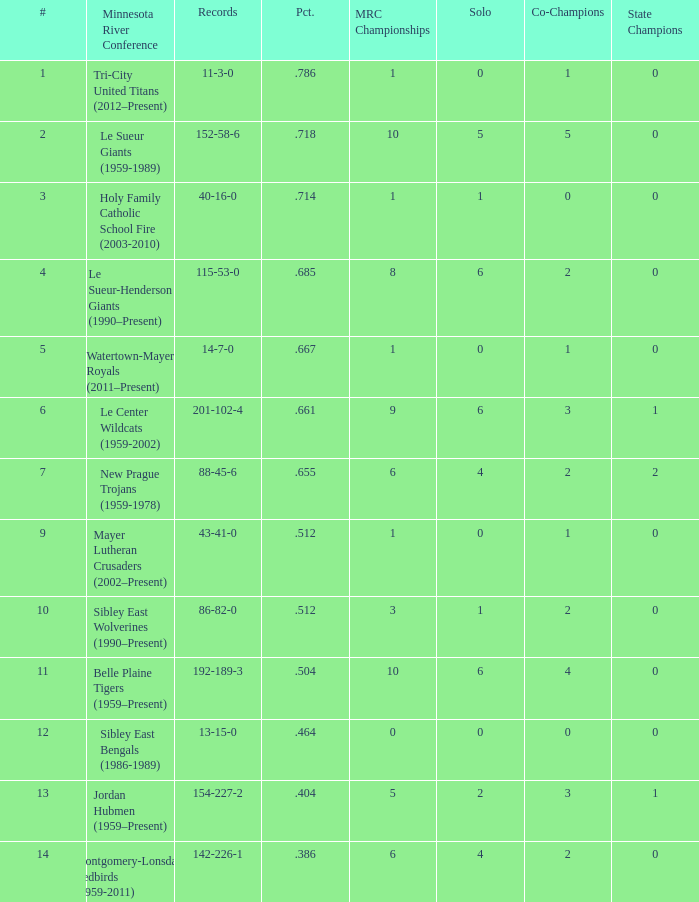How many teams are #2 on the list? 1.0. Would you mind parsing the complete table? {'header': ['#', 'Minnesota River Conference', 'Records', 'Pct.', 'MRC Championships', 'Solo', 'Co-Champions', 'State Champions'], 'rows': [['1', 'Tri-City United Titans (2012–Present)', '11-3-0', '.786', '1', '0', '1', '0'], ['2', 'Le Sueur Giants (1959-1989)', '152-58-6', '.718', '10', '5', '5', '0'], ['3', 'Holy Family Catholic School Fire (2003-2010)', '40-16-0', '.714', '1', '1', '0', '0'], ['4', 'Le Sueur-Henderson Giants (1990–Present)', '115-53-0', '.685', '8', '6', '2', '0'], ['5', 'Watertown-Mayer Royals (2011–Present)', '14-7-0', '.667', '1', '0', '1', '0'], ['6', 'Le Center Wildcats (1959-2002)', '201-102-4', '.661', '9', '6', '3', '1'], ['7', 'New Prague Trojans (1959-1978)', '88-45-6', '.655', '6', '4', '2', '2'], ['9', 'Mayer Lutheran Crusaders (2002–Present)', '43-41-0', '.512', '1', '0', '1', '0'], ['10', 'Sibley East Wolverines (1990–Present)', '86-82-0', '.512', '3', '1', '2', '0'], ['11', 'Belle Plaine Tigers (1959–Present)', '192-189-3', '.504', '10', '6', '4', '0'], ['12', 'Sibley East Bengals (1986-1989)', '13-15-0', '.464', '0', '0', '0', '0'], ['13', 'Jordan Hubmen (1959–Present)', '154-227-2', '.404', '5', '2', '3', '1'], ['14', 'Montgomery-Lonsdale Redbirds (1959-2011)', '142-226-1', '.386', '6', '4', '2', '0']]} 